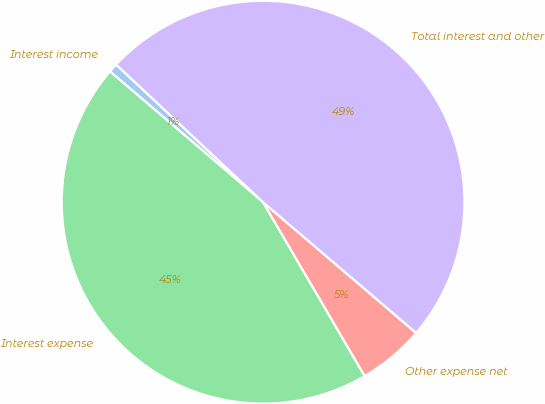Convert chart to OTSL. <chart><loc_0><loc_0><loc_500><loc_500><pie_chart><fcel>Interest income<fcel>Interest expense<fcel>Other expense net<fcel>Total interest and other<nl><fcel>0.73%<fcel>44.67%<fcel>5.33%<fcel>49.27%<nl></chart> 